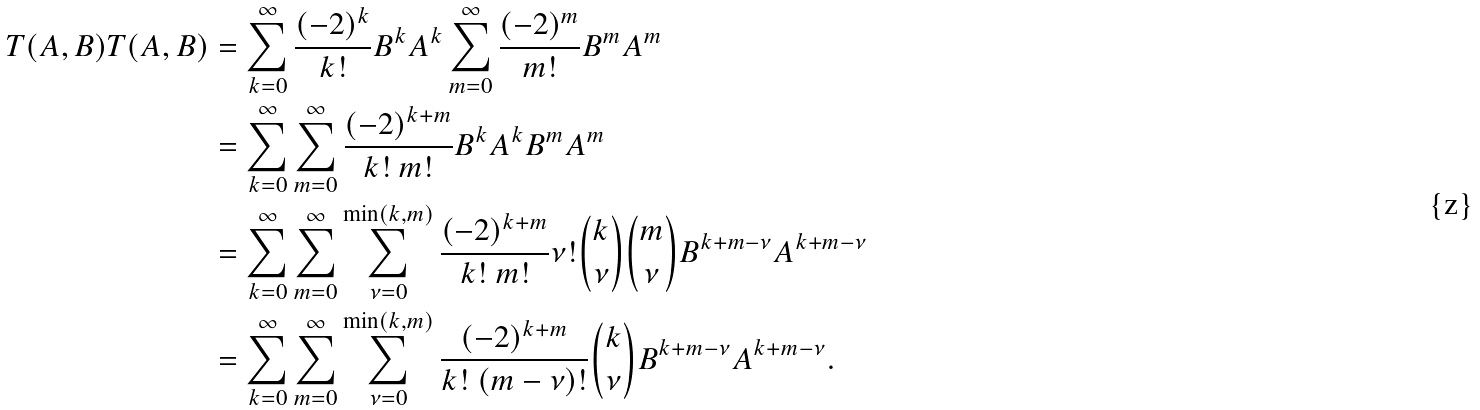<formula> <loc_0><loc_0><loc_500><loc_500>T ( A , B ) T ( A , B ) & = \sum _ { k = 0 } ^ { \infty } \frac { ( - 2 ) ^ { k } } { k ! } B ^ { k } A ^ { k } \sum _ { m = 0 } ^ { \infty } \frac { ( - 2 ) ^ { m } } { m ! } B ^ { m } A ^ { m } \\ & = \sum _ { k = 0 } ^ { \infty } \sum _ { m = 0 } ^ { \infty } \frac { ( - 2 ) ^ { k + m } } { k ! \ m ! } B ^ { k } A ^ { k } B ^ { m } A ^ { m } \\ & = \sum _ { k = 0 } ^ { \infty } \sum _ { m = 0 } ^ { \infty } \sum _ { \nu = 0 } ^ { \min ( k , m ) } \frac { ( - 2 ) ^ { k + m } } { k ! \ m ! } \nu ! \binom { k } { \nu } \binom { m } { \nu } B ^ { k + m - \nu } A ^ { k + m - \nu } \\ & = \sum _ { k = 0 } ^ { \infty } \sum _ { m = 0 } ^ { \infty } \sum _ { \nu = 0 } ^ { \min ( k , m ) } \frac { ( - 2 ) ^ { k + m } } { k ! \ ( m - \nu ) ! } \binom { k } { \nu } B ^ { k + m - \nu } A ^ { k + m - \nu } .</formula> 